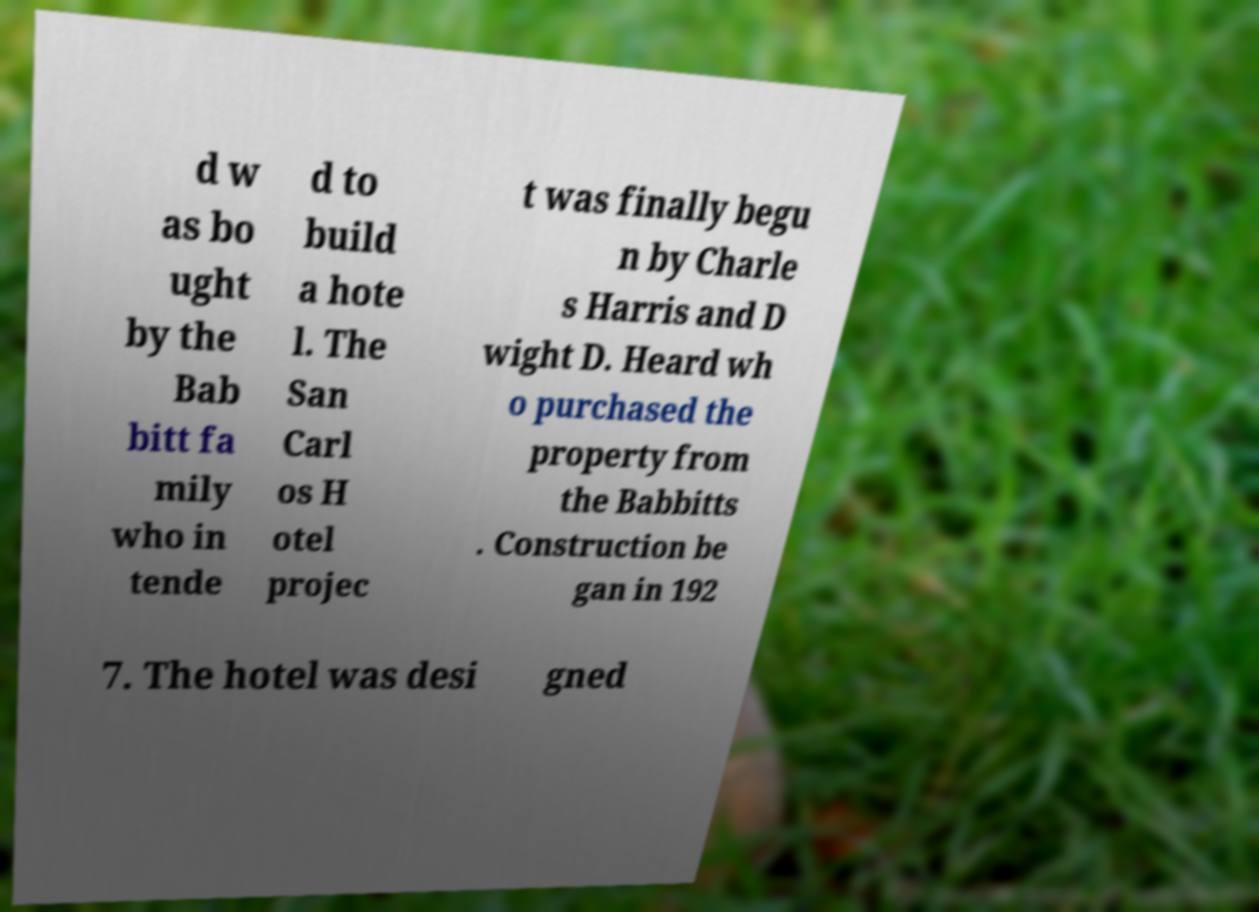Please identify and transcribe the text found in this image. d w as bo ught by the Bab bitt fa mily who in tende d to build a hote l. The San Carl os H otel projec t was finally begu n by Charle s Harris and D wight D. Heard wh o purchased the property from the Babbitts . Construction be gan in 192 7. The hotel was desi gned 